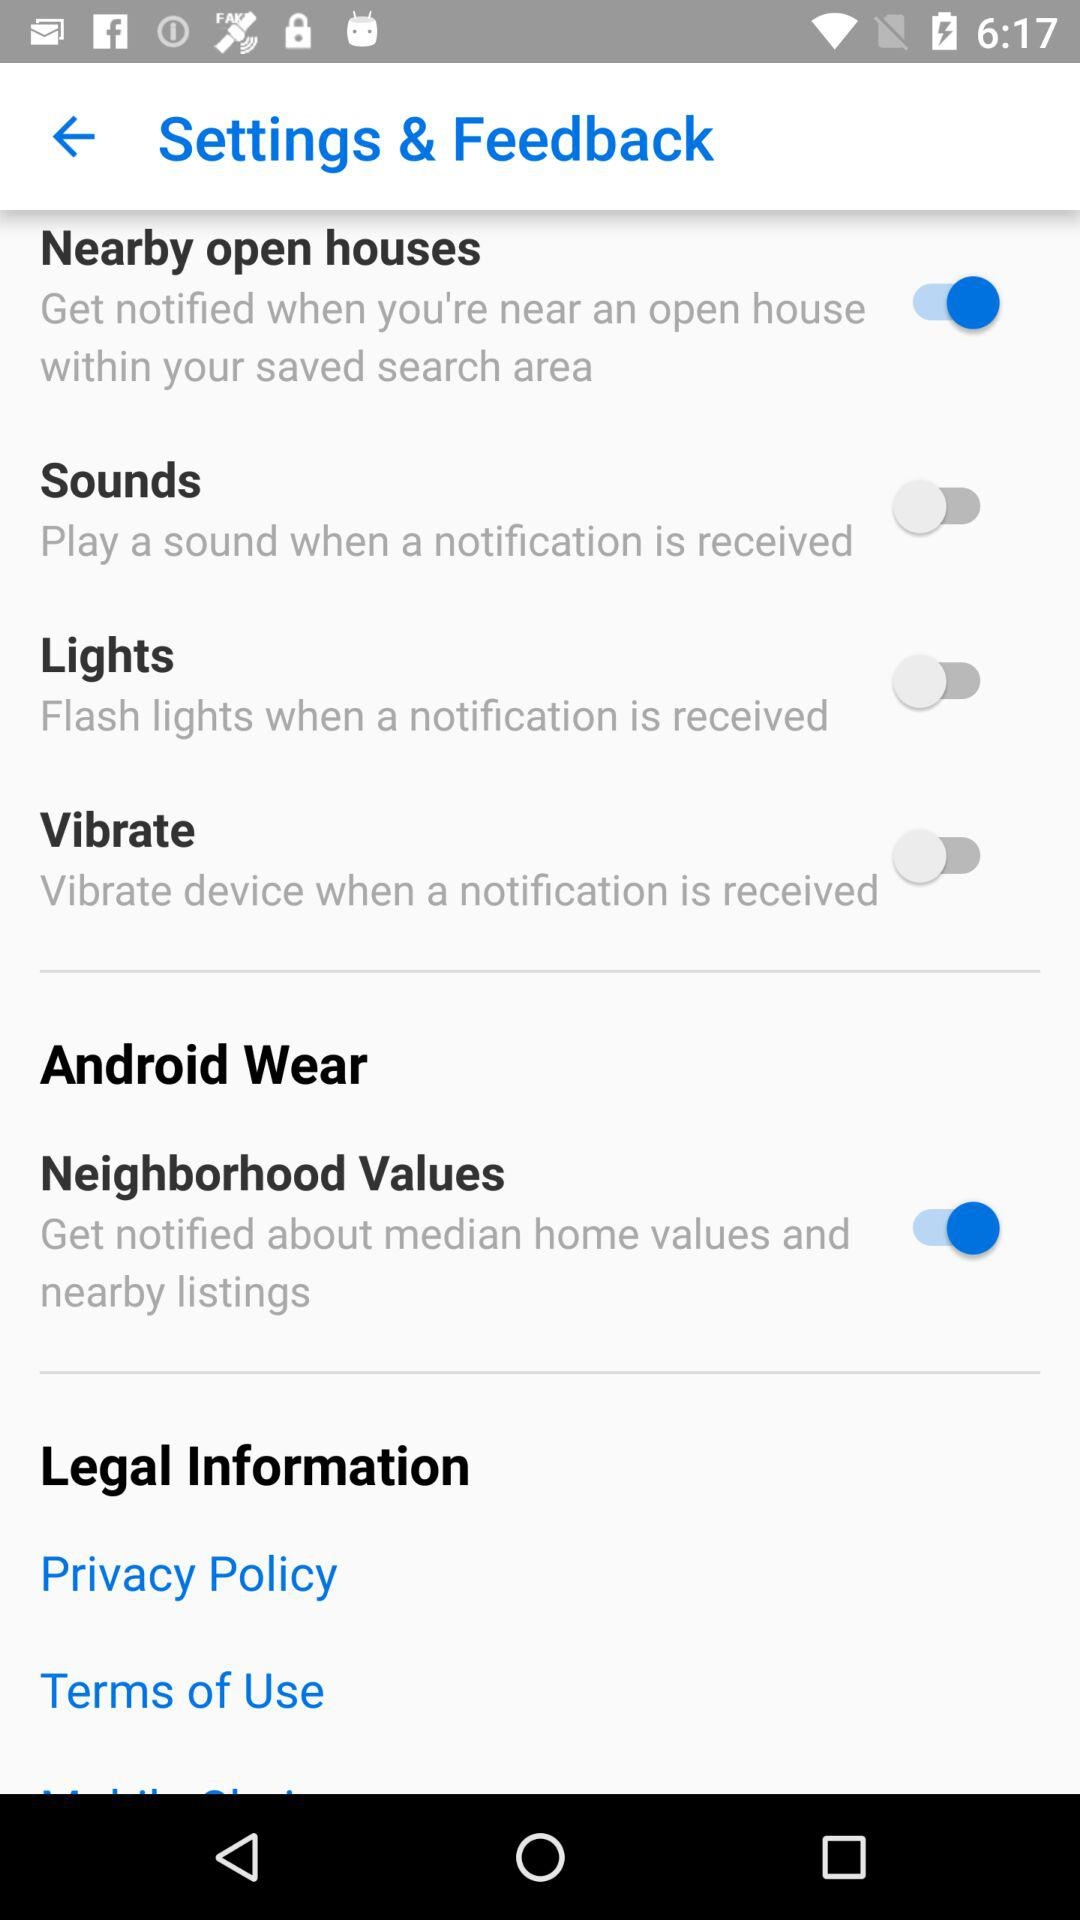What is the status of the "Sounds" and "Vibrate" settings? The status of the "Sounds" and "Vibrate" settings is off. 